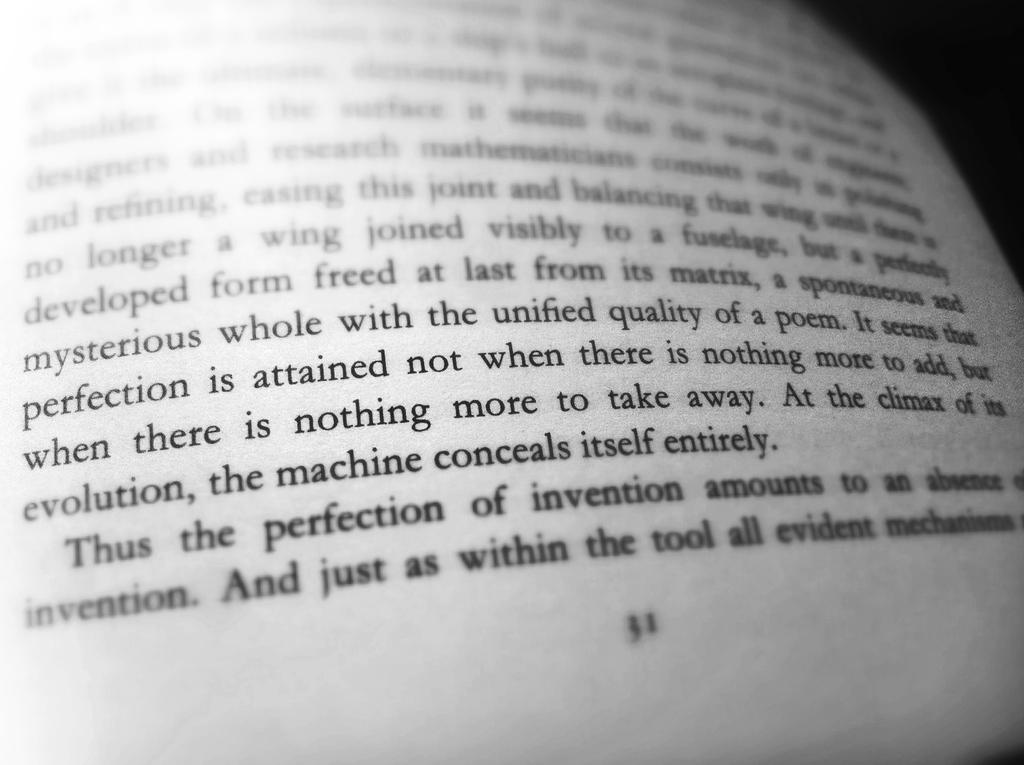Provide a one-sentence caption for the provided image. A passage in a book talking about attaining perfection. 